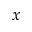<formula> <loc_0><loc_0><loc_500><loc_500>x</formula> 